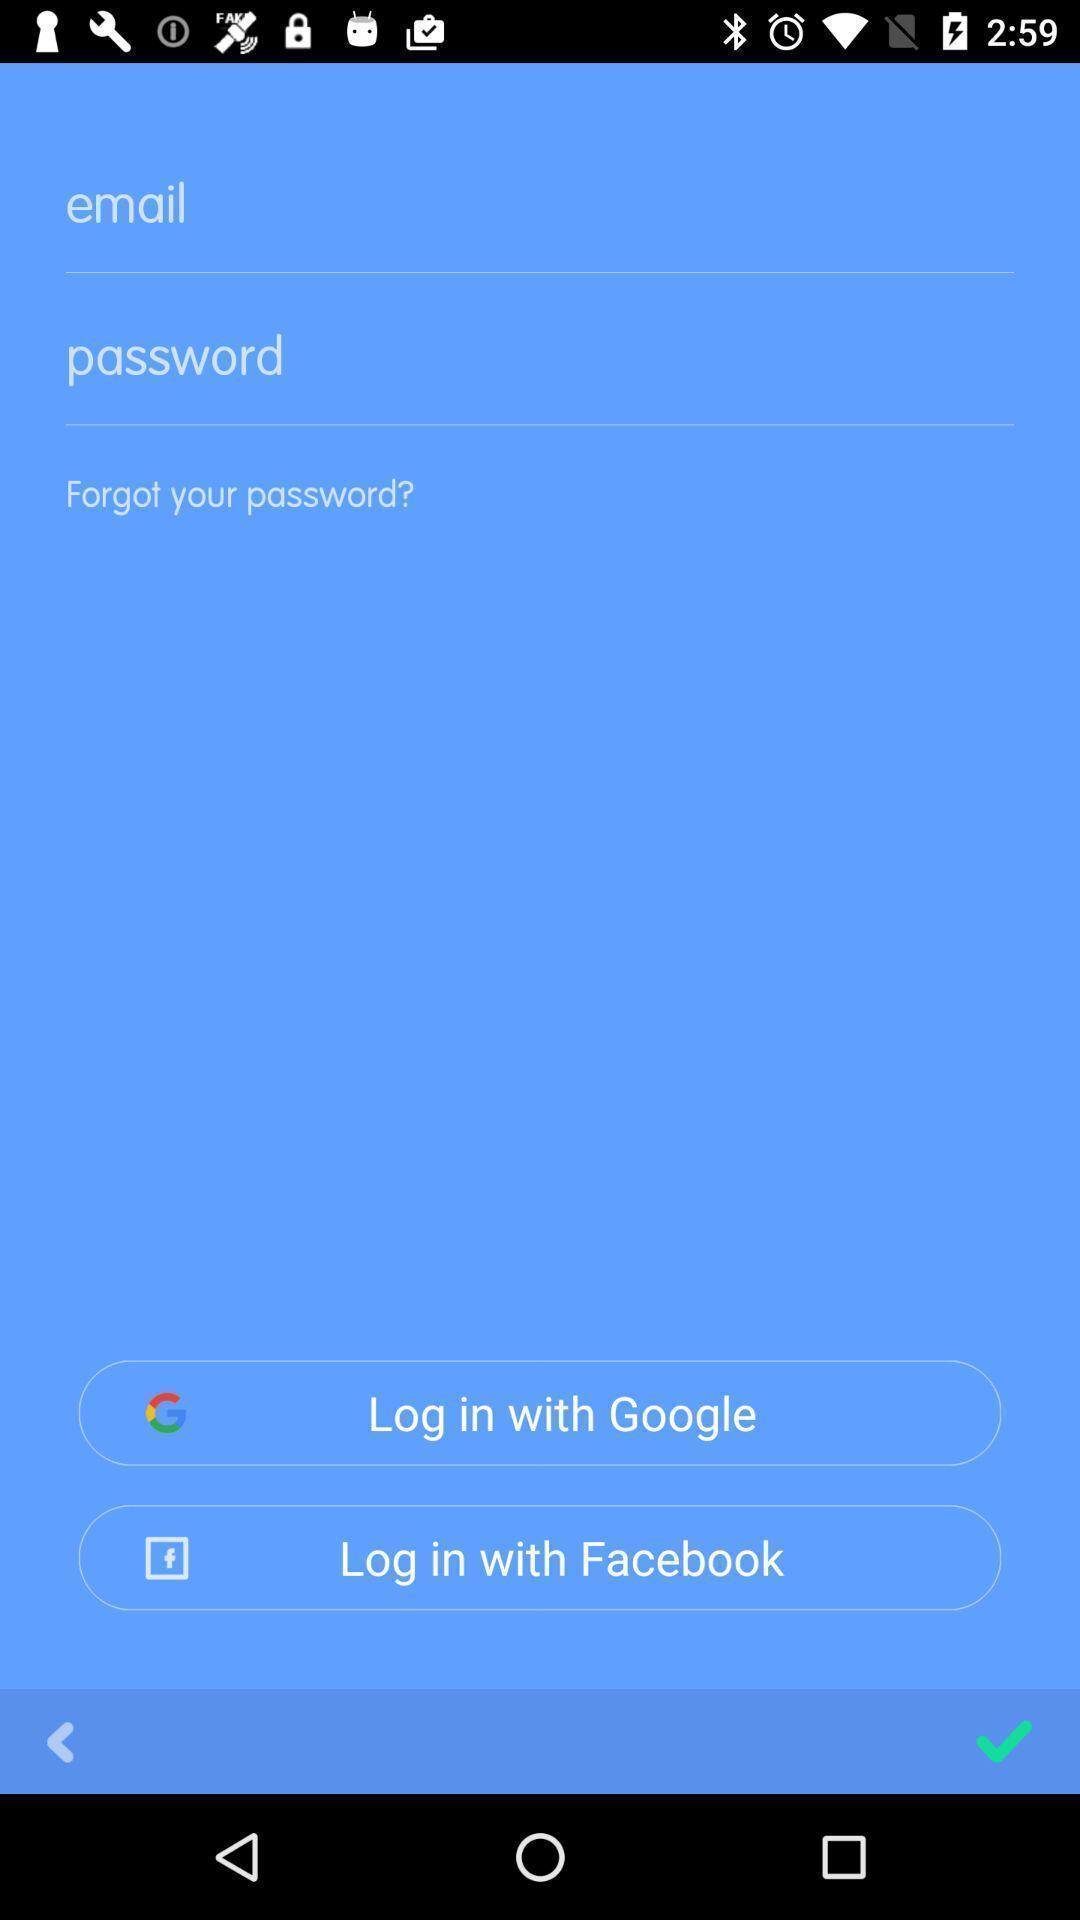Provide a description of this screenshot. Welcome page for logging into account. 